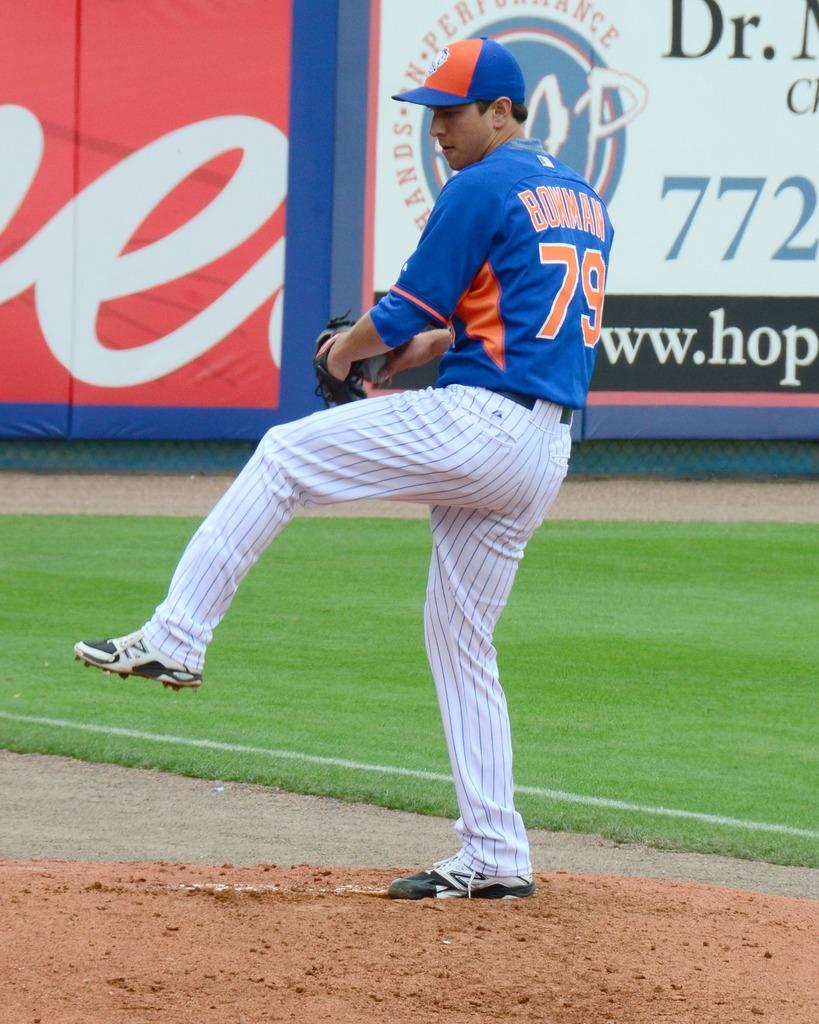<image>
Write a terse but informative summary of the picture. a person getting ready to throw a ball with the number 79 